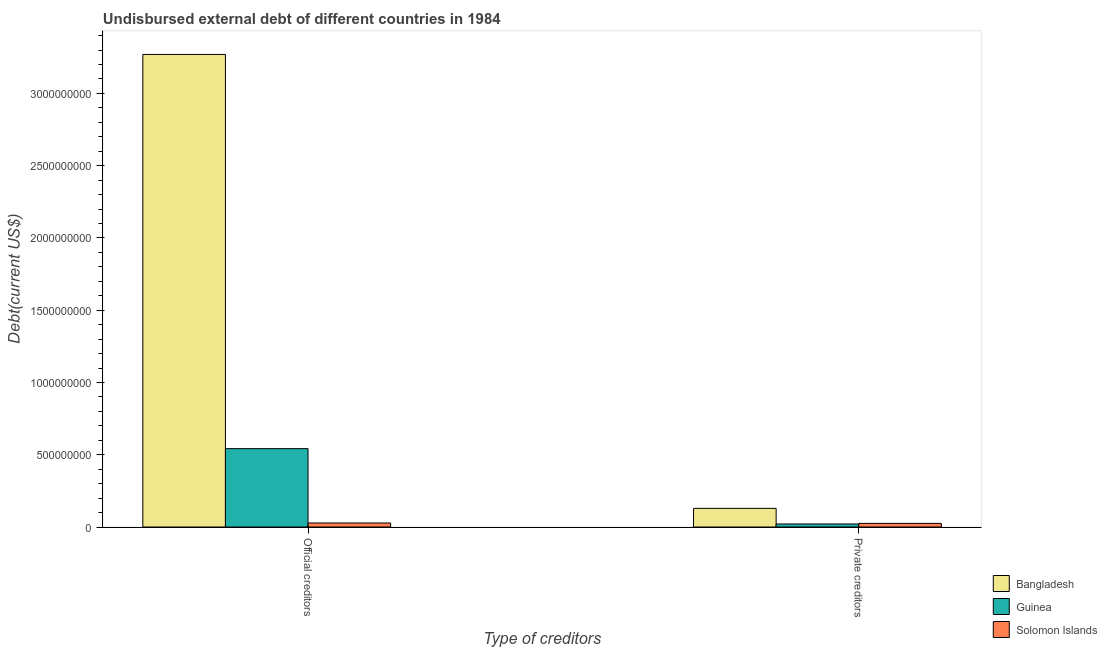How many different coloured bars are there?
Give a very brief answer. 3. How many groups of bars are there?
Make the answer very short. 2. Are the number of bars on each tick of the X-axis equal?
Your answer should be compact. Yes. What is the label of the 1st group of bars from the left?
Keep it short and to the point. Official creditors. What is the undisbursed external debt of official creditors in Bangladesh?
Offer a terse response. 3.27e+09. Across all countries, what is the maximum undisbursed external debt of official creditors?
Provide a short and direct response. 3.27e+09. Across all countries, what is the minimum undisbursed external debt of private creditors?
Provide a short and direct response. 2.10e+07. In which country was the undisbursed external debt of official creditors maximum?
Give a very brief answer. Bangladesh. In which country was the undisbursed external debt of private creditors minimum?
Ensure brevity in your answer.  Guinea. What is the total undisbursed external debt of private creditors in the graph?
Your answer should be compact. 1.75e+08. What is the difference between the undisbursed external debt of private creditors in Guinea and that in Bangladesh?
Keep it short and to the point. -1.08e+08. What is the difference between the undisbursed external debt of private creditors in Bangladesh and the undisbursed external debt of official creditors in Solomon Islands?
Make the answer very short. 1.01e+08. What is the average undisbursed external debt of official creditors per country?
Provide a short and direct response. 1.28e+09. What is the difference between the undisbursed external debt of official creditors and undisbursed external debt of private creditors in Guinea?
Make the answer very short. 5.21e+08. What is the ratio of the undisbursed external debt of official creditors in Bangladesh to that in Guinea?
Offer a very short reply. 6.03. In how many countries, is the undisbursed external debt of private creditors greater than the average undisbursed external debt of private creditors taken over all countries?
Make the answer very short. 1. What does the 2nd bar from the left in Official creditors represents?
Your answer should be very brief. Guinea. What does the 2nd bar from the right in Private creditors represents?
Your response must be concise. Guinea. How many bars are there?
Give a very brief answer. 6. Are all the bars in the graph horizontal?
Your response must be concise. No. What is the difference between two consecutive major ticks on the Y-axis?
Offer a very short reply. 5.00e+08. Are the values on the major ticks of Y-axis written in scientific E-notation?
Your answer should be very brief. No. Does the graph contain any zero values?
Keep it short and to the point. No. How many legend labels are there?
Your answer should be compact. 3. How are the legend labels stacked?
Offer a terse response. Vertical. What is the title of the graph?
Your answer should be compact. Undisbursed external debt of different countries in 1984. Does "Other small states" appear as one of the legend labels in the graph?
Your answer should be compact. No. What is the label or title of the X-axis?
Keep it short and to the point. Type of creditors. What is the label or title of the Y-axis?
Provide a succinct answer. Debt(current US$). What is the Debt(current US$) in Bangladesh in Official creditors?
Make the answer very short. 3.27e+09. What is the Debt(current US$) of Guinea in Official creditors?
Provide a succinct answer. 5.42e+08. What is the Debt(current US$) of Solomon Islands in Official creditors?
Provide a succinct answer. 2.79e+07. What is the Debt(current US$) in Bangladesh in Private creditors?
Provide a short and direct response. 1.29e+08. What is the Debt(current US$) of Guinea in Private creditors?
Give a very brief answer. 2.10e+07. What is the Debt(current US$) in Solomon Islands in Private creditors?
Offer a terse response. 2.50e+07. Across all Type of creditors, what is the maximum Debt(current US$) of Bangladesh?
Ensure brevity in your answer.  3.27e+09. Across all Type of creditors, what is the maximum Debt(current US$) in Guinea?
Give a very brief answer. 5.42e+08. Across all Type of creditors, what is the maximum Debt(current US$) in Solomon Islands?
Give a very brief answer. 2.79e+07. Across all Type of creditors, what is the minimum Debt(current US$) of Bangladesh?
Provide a succinct answer. 1.29e+08. Across all Type of creditors, what is the minimum Debt(current US$) of Guinea?
Ensure brevity in your answer.  2.10e+07. Across all Type of creditors, what is the minimum Debt(current US$) of Solomon Islands?
Offer a terse response. 2.50e+07. What is the total Debt(current US$) in Bangladesh in the graph?
Your answer should be compact. 3.40e+09. What is the total Debt(current US$) in Guinea in the graph?
Offer a very short reply. 5.63e+08. What is the total Debt(current US$) of Solomon Islands in the graph?
Keep it short and to the point. 5.29e+07. What is the difference between the Debt(current US$) of Bangladesh in Official creditors and that in Private creditors?
Offer a terse response. 3.14e+09. What is the difference between the Debt(current US$) in Guinea in Official creditors and that in Private creditors?
Provide a succinct answer. 5.21e+08. What is the difference between the Debt(current US$) in Solomon Islands in Official creditors and that in Private creditors?
Offer a very short reply. 2.92e+06. What is the difference between the Debt(current US$) in Bangladesh in Official creditors and the Debt(current US$) in Guinea in Private creditors?
Your response must be concise. 3.25e+09. What is the difference between the Debt(current US$) of Bangladesh in Official creditors and the Debt(current US$) of Solomon Islands in Private creditors?
Provide a short and direct response. 3.24e+09. What is the difference between the Debt(current US$) in Guinea in Official creditors and the Debt(current US$) in Solomon Islands in Private creditors?
Keep it short and to the point. 5.17e+08. What is the average Debt(current US$) in Bangladesh per Type of creditors?
Give a very brief answer. 1.70e+09. What is the average Debt(current US$) of Guinea per Type of creditors?
Your answer should be very brief. 2.82e+08. What is the average Debt(current US$) of Solomon Islands per Type of creditors?
Your answer should be very brief. 2.65e+07. What is the difference between the Debt(current US$) of Bangladesh and Debt(current US$) of Guinea in Official creditors?
Offer a very short reply. 2.73e+09. What is the difference between the Debt(current US$) in Bangladesh and Debt(current US$) in Solomon Islands in Official creditors?
Make the answer very short. 3.24e+09. What is the difference between the Debt(current US$) in Guinea and Debt(current US$) in Solomon Islands in Official creditors?
Give a very brief answer. 5.14e+08. What is the difference between the Debt(current US$) of Bangladesh and Debt(current US$) of Guinea in Private creditors?
Provide a succinct answer. 1.08e+08. What is the difference between the Debt(current US$) in Bangladesh and Debt(current US$) in Solomon Islands in Private creditors?
Provide a succinct answer. 1.04e+08. What is the difference between the Debt(current US$) of Guinea and Debt(current US$) of Solomon Islands in Private creditors?
Provide a succinct answer. -3.98e+06. What is the ratio of the Debt(current US$) in Bangladesh in Official creditors to that in Private creditors?
Ensure brevity in your answer.  25.33. What is the ratio of the Debt(current US$) of Guinea in Official creditors to that in Private creditors?
Provide a succinct answer. 25.78. What is the ratio of the Debt(current US$) of Solomon Islands in Official creditors to that in Private creditors?
Offer a terse response. 1.12. What is the difference between the highest and the second highest Debt(current US$) in Bangladesh?
Your answer should be compact. 3.14e+09. What is the difference between the highest and the second highest Debt(current US$) in Guinea?
Provide a short and direct response. 5.21e+08. What is the difference between the highest and the second highest Debt(current US$) in Solomon Islands?
Provide a short and direct response. 2.92e+06. What is the difference between the highest and the lowest Debt(current US$) in Bangladesh?
Your answer should be compact. 3.14e+09. What is the difference between the highest and the lowest Debt(current US$) in Guinea?
Your answer should be very brief. 5.21e+08. What is the difference between the highest and the lowest Debt(current US$) of Solomon Islands?
Your answer should be compact. 2.92e+06. 